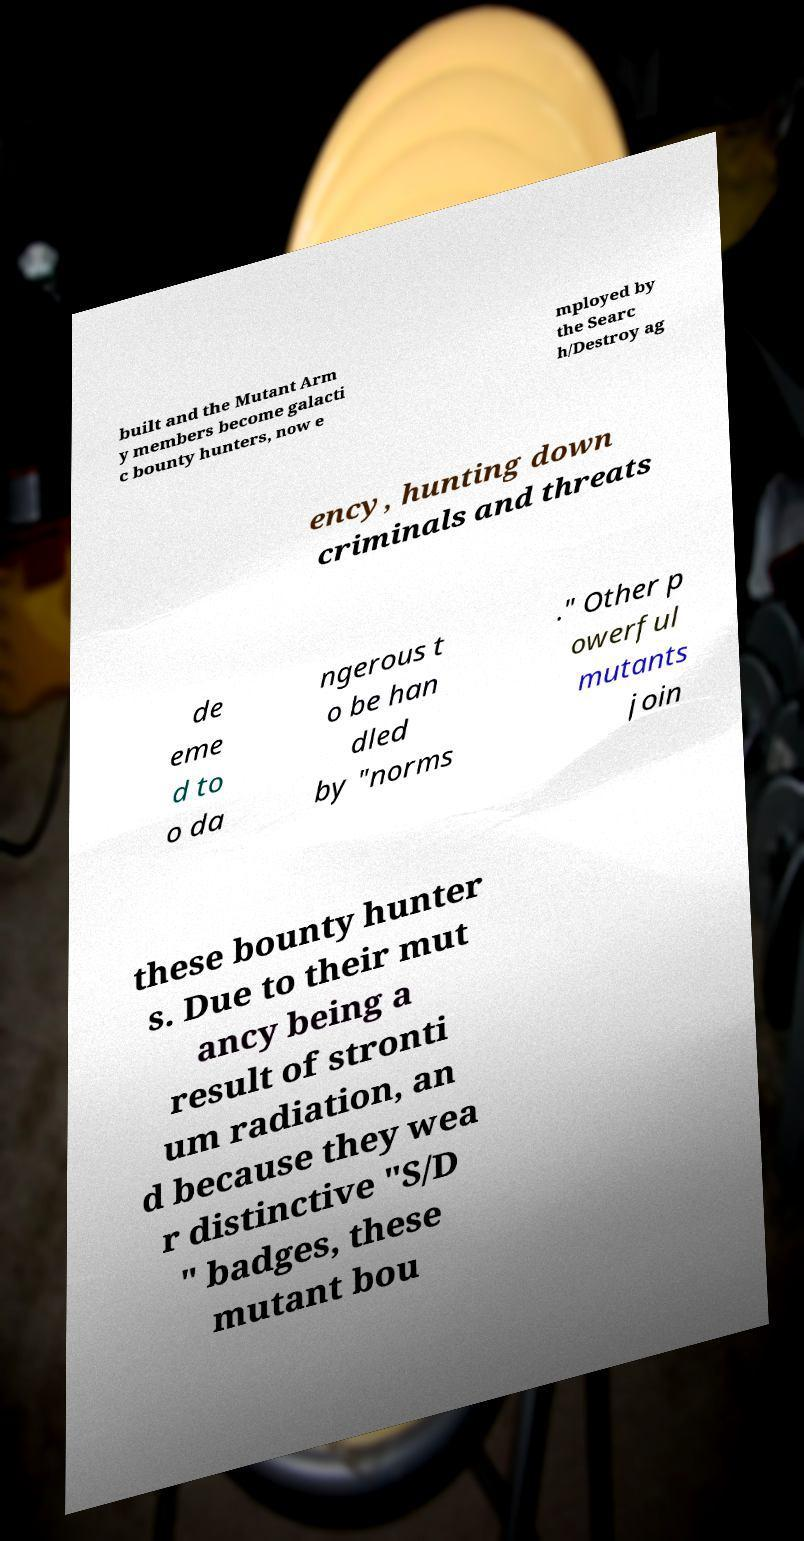Could you assist in decoding the text presented in this image and type it out clearly? built and the Mutant Arm y members become galacti c bounty hunters, now e mployed by the Searc h/Destroy ag ency, hunting down criminals and threats de eme d to o da ngerous t o be han dled by "norms ." Other p owerful mutants join these bounty hunter s. Due to their mut ancy being a result of stronti um radiation, an d because they wea r distinctive "S/D " badges, these mutant bou 